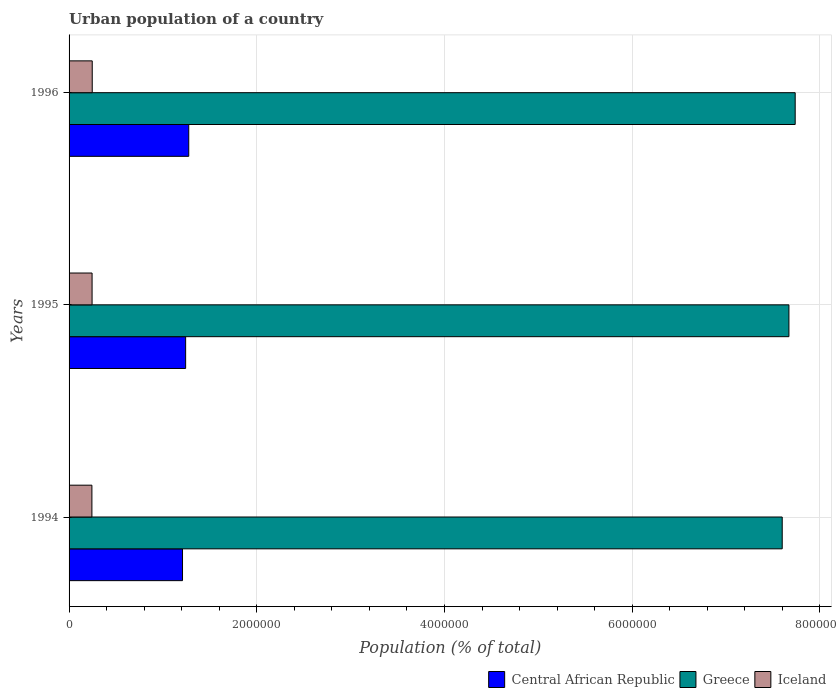How many different coloured bars are there?
Offer a terse response. 3. Are the number of bars per tick equal to the number of legend labels?
Provide a short and direct response. Yes. Are the number of bars on each tick of the Y-axis equal?
Offer a very short reply. Yes. How many bars are there on the 1st tick from the top?
Offer a very short reply. 3. What is the label of the 3rd group of bars from the top?
Your response must be concise. 1994. What is the urban population in Greece in 1995?
Offer a very short reply. 7.67e+06. Across all years, what is the maximum urban population in Iceland?
Offer a terse response. 2.47e+05. Across all years, what is the minimum urban population in Central African Republic?
Your answer should be compact. 1.21e+06. In which year was the urban population in Iceland maximum?
Your answer should be very brief. 1996. In which year was the urban population in Greece minimum?
Provide a short and direct response. 1994. What is the total urban population in Central African Republic in the graph?
Make the answer very short. 3.73e+06. What is the difference between the urban population in Greece in 1995 and that in 1996?
Offer a terse response. -6.68e+04. What is the difference between the urban population in Iceland in 1996 and the urban population in Greece in 1995?
Your answer should be compact. -7.42e+06. What is the average urban population in Iceland per year?
Offer a terse response. 2.45e+05. In the year 1994, what is the difference between the urban population in Greece and urban population in Central African Republic?
Your answer should be very brief. 6.39e+06. In how many years, is the urban population in Central African Republic greater than 4400000 %?
Provide a succinct answer. 0. What is the ratio of the urban population in Central African Republic in 1994 to that in 1995?
Offer a terse response. 0.97. Is the difference between the urban population in Greece in 1994 and 1995 greater than the difference between the urban population in Central African Republic in 1994 and 1995?
Your response must be concise. No. What is the difference between the highest and the second highest urban population in Iceland?
Your response must be concise. 1776. What is the difference between the highest and the lowest urban population in Iceland?
Offer a terse response. 3554. In how many years, is the urban population in Central African Republic greater than the average urban population in Central African Republic taken over all years?
Offer a very short reply. 2. Is the sum of the urban population in Central African Republic in 1994 and 1995 greater than the maximum urban population in Iceland across all years?
Provide a succinct answer. Yes. What does the 3rd bar from the top in 1996 represents?
Your response must be concise. Central African Republic. Is it the case that in every year, the sum of the urban population in Greece and urban population in Iceland is greater than the urban population in Central African Republic?
Make the answer very short. Yes. How many bars are there?
Make the answer very short. 9. Does the graph contain any zero values?
Give a very brief answer. No. Where does the legend appear in the graph?
Ensure brevity in your answer.  Bottom right. How are the legend labels stacked?
Offer a very short reply. Horizontal. What is the title of the graph?
Make the answer very short. Urban population of a country. Does "Czech Republic" appear as one of the legend labels in the graph?
Provide a succinct answer. No. What is the label or title of the X-axis?
Your response must be concise. Population (% of total). What is the label or title of the Y-axis?
Your response must be concise. Years. What is the Population (% of total) of Central African Republic in 1994?
Offer a terse response. 1.21e+06. What is the Population (% of total) of Greece in 1994?
Offer a very short reply. 7.60e+06. What is the Population (% of total) of Iceland in 1994?
Give a very brief answer. 2.43e+05. What is the Population (% of total) of Central African Republic in 1995?
Give a very brief answer. 1.24e+06. What is the Population (% of total) of Greece in 1995?
Offer a very short reply. 7.67e+06. What is the Population (% of total) in Iceland in 1995?
Provide a succinct answer. 2.45e+05. What is the Population (% of total) in Central African Republic in 1996?
Give a very brief answer. 1.28e+06. What is the Population (% of total) in Greece in 1996?
Provide a succinct answer. 7.74e+06. What is the Population (% of total) of Iceland in 1996?
Provide a succinct answer. 2.47e+05. Across all years, what is the maximum Population (% of total) in Central African Republic?
Provide a succinct answer. 1.28e+06. Across all years, what is the maximum Population (% of total) of Greece?
Offer a terse response. 7.74e+06. Across all years, what is the maximum Population (% of total) of Iceland?
Your answer should be compact. 2.47e+05. Across all years, what is the minimum Population (% of total) of Central African Republic?
Offer a terse response. 1.21e+06. Across all years, what is the minimum Population (% of total) of Greece?
Provide a succinct answer. 7.60e+06. Across all years, what is the minimum Population (% of total) of Iceland?
Keep it short and to the point. 2.43e+05. What is the total Population (% of total) in Central African Republic in the graph?
Your response must be concise. 3.73e+06. What is the total Population (% of total) of Greece in the graph?
Keep it short and to the point. 2.30e+07. What is the total Population (% of total) in Iceland in the graph?
Provide a short and direct response. 7.35e+05. What is the difference between the Population (% of total) of Central African Republic in 1994 and that in 1995?
Offer a very short reply. -3.33e+04. What is the difference between the Population (% of total) in Greece in 1994 and that in 1995?
Ensure brevity in your answer.  -7.14e+04. What is the difference between the Population (% of total) of Iceland in 1994 and that in 1995?
Offer a very short reply. -1778. What is the difference between the Population (% of total) in Central African Republic in 1994 and that in 1996?
Your answer should be very brief. -6.63e+04. What is the difference between the Population (% of total) in Greece in 1994 and that in 1996?
Your response must be concise. -1.38e+05. What is the difference between the Population (% of total) of Iceland in 1994 and that in 1996?
Make the answer very short. -3554. What is the difference between the Population (% of total) of Central African Republic in 1995 and that in 1996?
Offer a terse response. -3.30e+04. What is the difference between the Population (% of total) in Greece in 1995 and that in 1996?
Ensure brevity in your answer.  -6.68e+04. What is the difference between the Population (% of total) in Iceland in 1995 and that in 1996?
Your response must be concise. -1776. What is the difference between the Population (% of total) in Central African Republic in 1994 and the Population (% of total) in Greece in 1995?
Provide a succinct answer. -6.46e+06. What is the difference between the Population (% of total) in Central African Republic in 1994 and the Population (% of total) in Iceland in 1995?
Offer a terse response. 9.64e+05. What is the difference between the Population (% of total) in Greece in 1994 and the Population (% of total) in Iceland in 1995?
Provide a short and direct response. 7.35e+06. What is the difference between the Population (% of total) of Central African Republic in 1994 and the Population (% of total) of Greece in 1996?
Offer a terse response. -6.53e+06. What is the difference between the Population (% of total) of Central African Republic in 1994 and the Population (% of total) of Iceland in 1996?
Provide a short and direct response. 9.62e+05. What is the difference between the Population (% of total) of Greece in 1994 and the Population (% of total) of Iceland in 1996?
Ensure brevity in your answer.  7.35e+06. What is the difference between the Population (% of total) of Central African Republic in 1995 and the Population (% of total) of Greece in 1996?
Your answer should be compact. -6.49e+06. What is the difference between the Population (% of total) in Central African Republic in 1995 and the Population (% of total) in Iceland in 1996?
Ensure brevity in your answer.  9.95e+05. What is the difference between the Population (% of total) in Greece in 1995 and the Population (% of total) in Iceland in 1996?
Keep it short and to the point. 7.42e+06. What is the average Population (% of total) in Central African Republic per year?
Give a very brief answer. 1.24e+06. What is the average Population (% of total) in Greece per year?
Your answer should be very brief. 7.67e+06. What is the average Population (% of total) in Iceland per year?
Offer a very short reply. 2.45e+05. In the year 1994, what is the difference between the Population (% of total) of Central African Republic and Population (% of total) of Greece?
Ensure brevity in your answer.  -6.39e+06. In the year 1994, what is the difference between the Population (% of total) in Central African Republic and Population (% of total) in Iceland?
Ensure brevity in your answer.  9.65e+05. In the year 1994, what is the difference between the Population (% of total) in Greece and Population (% of total) in Iceland?
Ensure brevity in your answer.  7.35e+06. In the year 1995, what is the difference between the Population (% of total) in Central African Republic and Population (% of total) in Greece?
Keep it short and to the point. -6.43e+06. In the year 1995, what is the difference between the Population (% of total) of Central African Republic and Population (% of total) of Iceland?
Give a very brief answer. 9.97e+05. In the year 1995, what is the difference between the Population (% of total) in Greece and Population (% of total) in Iceland?
Your answer should be compact. 7.42e+06. In the year 1996, what is the difference between the Population (% of total) in Central African Republic and Population (% of total) in Greece?
Offer a very short reply. -6.46e+06. In the year 1996, what is the difference between the Population (% of total) in Central African Republic and Population (% of total) in Iceland?
Your answer should be compact. 1.03e+06. In the year 1996, what is the difference between the Population (% of total) in Greece and Population (% of total) in Iceland?
Offer a very short reply. 7.49e+06. What is the ratio of the Population (% of total) of Central African Republic in 1994 to that in 1995?
Your response must be concise. 0.97. What is the ratio of the Population (% of total) of Central African Republic in 1994 to that in 1996?
Keep it short and to the point. 0.95. What is the ratio of the Population (% of total) in Greece in 1994 to that in 1996?
Offer a terse response. 0.98. What is the ratio of the Population (% of total) in Iceland in 1994 to that in 1996?
Your answer should be compact. 0.99. What is the ratio of the Population (% of total) in Central African Republic in 1995 to that in 1996?
Ensure brevity in your answer.  0.97. What is the ratio of the Population (% of total) in Greece in 1995 to that in 1996?
Give a very brief answer. 0.99. What is the ratio of the Population (% of total) in Iceland in 1995 to that in 1996?
Your answer should be compact. 0.99. What is the difference between the highest and the second highest Population (% of total) in Central African Republic?
Make the answer very short. 3.30e+04. What is the difference between the highest and the second highest Population (% of total) of Greece?
Your answer should be very brief. 6.68e+04. What is the difference between the highest and the second highest Population (% of total) in Iceland?
Provide a short and direct response. 1776. What is the difference between the highest and the lowest Population (% of total) of Central African Republic?
Your answer should be very brief. 6.63e+04. What is the difference between the highest and the lowest Population (% of total) in Greece?
Ensure brevity in your answer.  1.38e+05. What is the difference between the highest and the lowest Population (% of total) of Iceland?
Keep it short and to the point. 3554. 